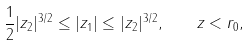<formula> <loc_0><loc_0><loc_500><loc_500>\frac { 1 } { 2 } | z _ { 2 } | ^ { 3 / 2 } \leq | z _ { 1 } | \leq | z _ { 2 } | ^ { 3 / 2 } , \quad \| z \| < r _ { 0 } ,</formula> 